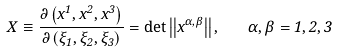Convert formula to latex. <formula><loc_0><loc_0><loc_500><loc_500>X \equiv \frac { \partial \left ( x ^ { 1 } , x ^ { 2 } , x ^ { 3 } \right ) } { \partial \left ( \xi _ { 1 } , \xi _ { 2 } , \xi _ { 3 } \right ) } = \det \left | \left | x ^ { \alpha , \beta } \right | \right | , \quad \alpha , \beta = 1 , 2 , 3</formula> 